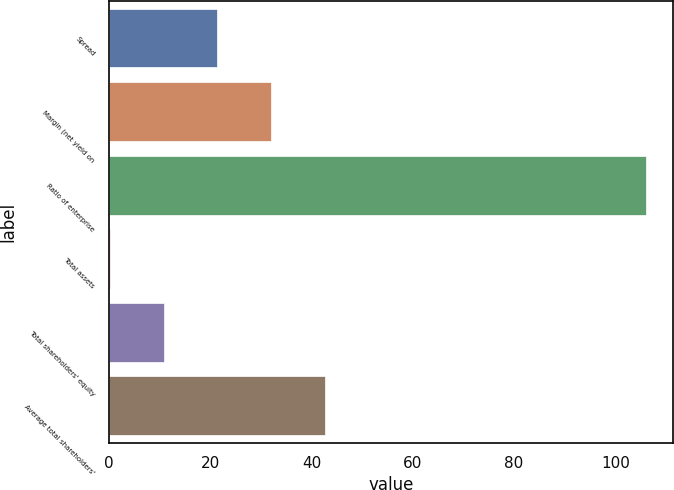Convert chart. <chart><loc_0><loc_0><loc_500><loc_500><bar_chart><fcel>Spread<fcel>Margin (net yield on<fcel>Ratio of enterprise<fcel>Total assets<fcel>Total shareholders' equity<fcel>Average total shareholders'<nl><fcel>21.41<fcel>32<fcel>106.09<fcel>0.23<fcel>10.82<fcel>42.59<nl></chart> 